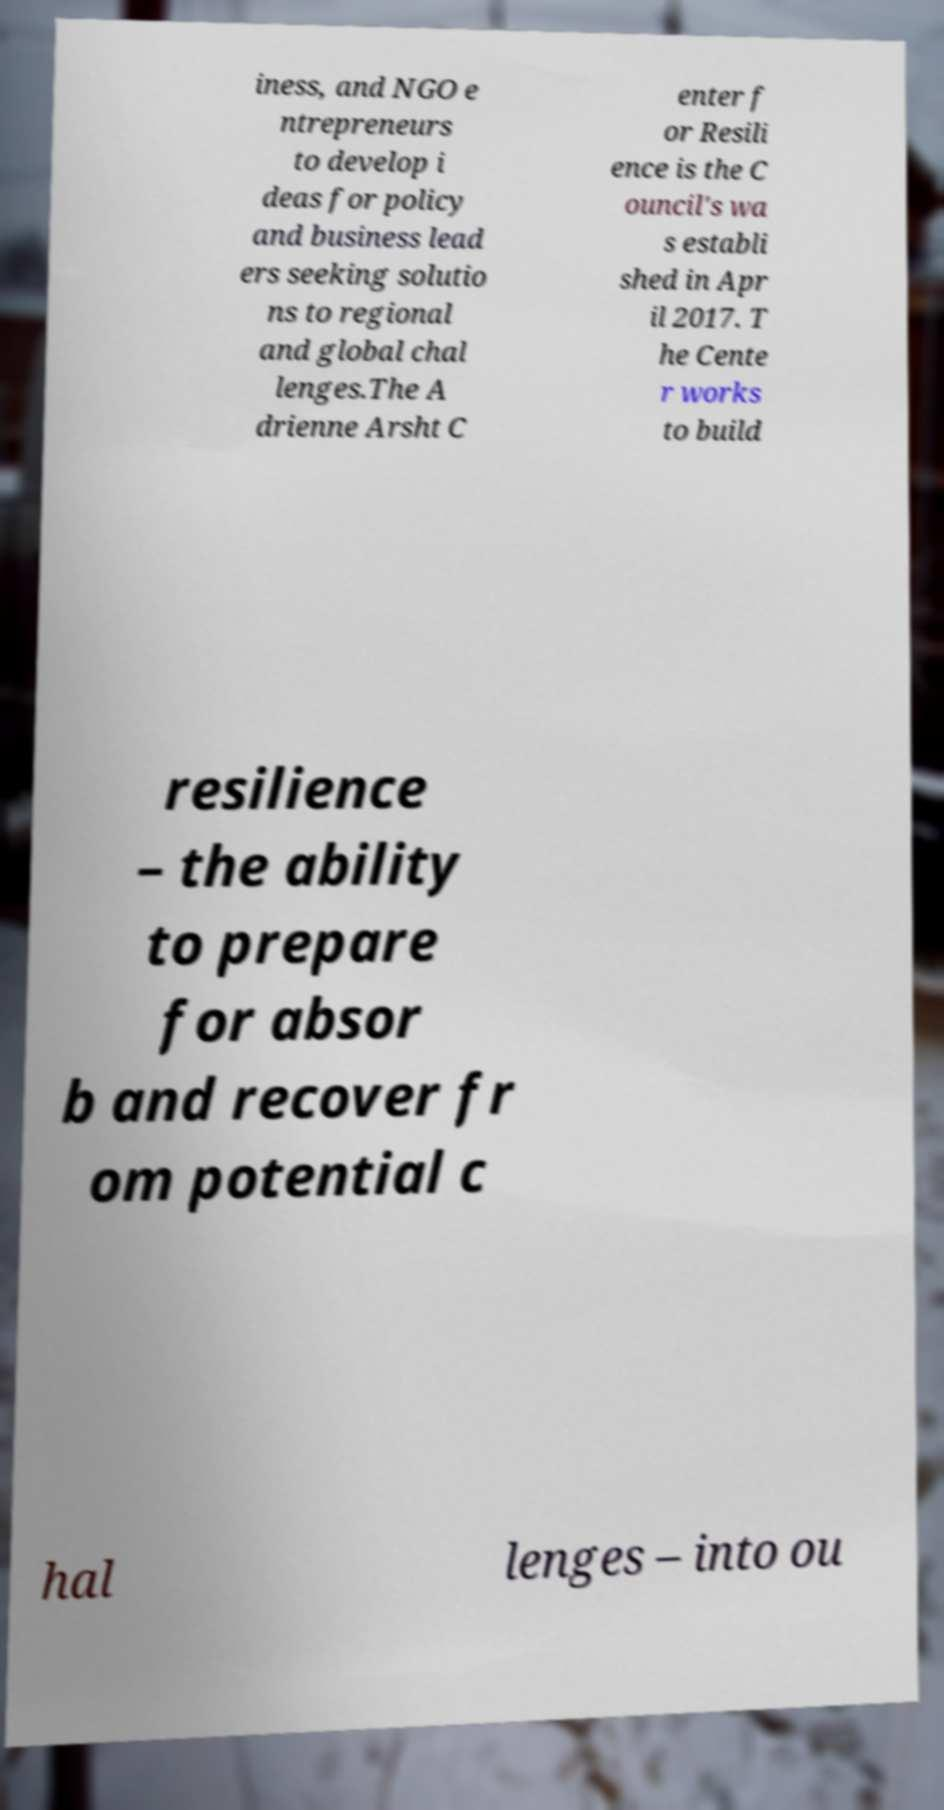What messages or text are displayed in this image? I need them in a readable, typed format. iness, and NGO e ntrepreneurs to develop i deas for policy and business lead ers seeking solutio ns to regional and global chal lenges.The A drienne Arsht C enter f or Resili ence is the C ouncil's wa s establi shed in Apr il 2017. T he Cente r works to build resilience – the ability to prepare for absor b and recover fr om potential c hal lenges – into ou 